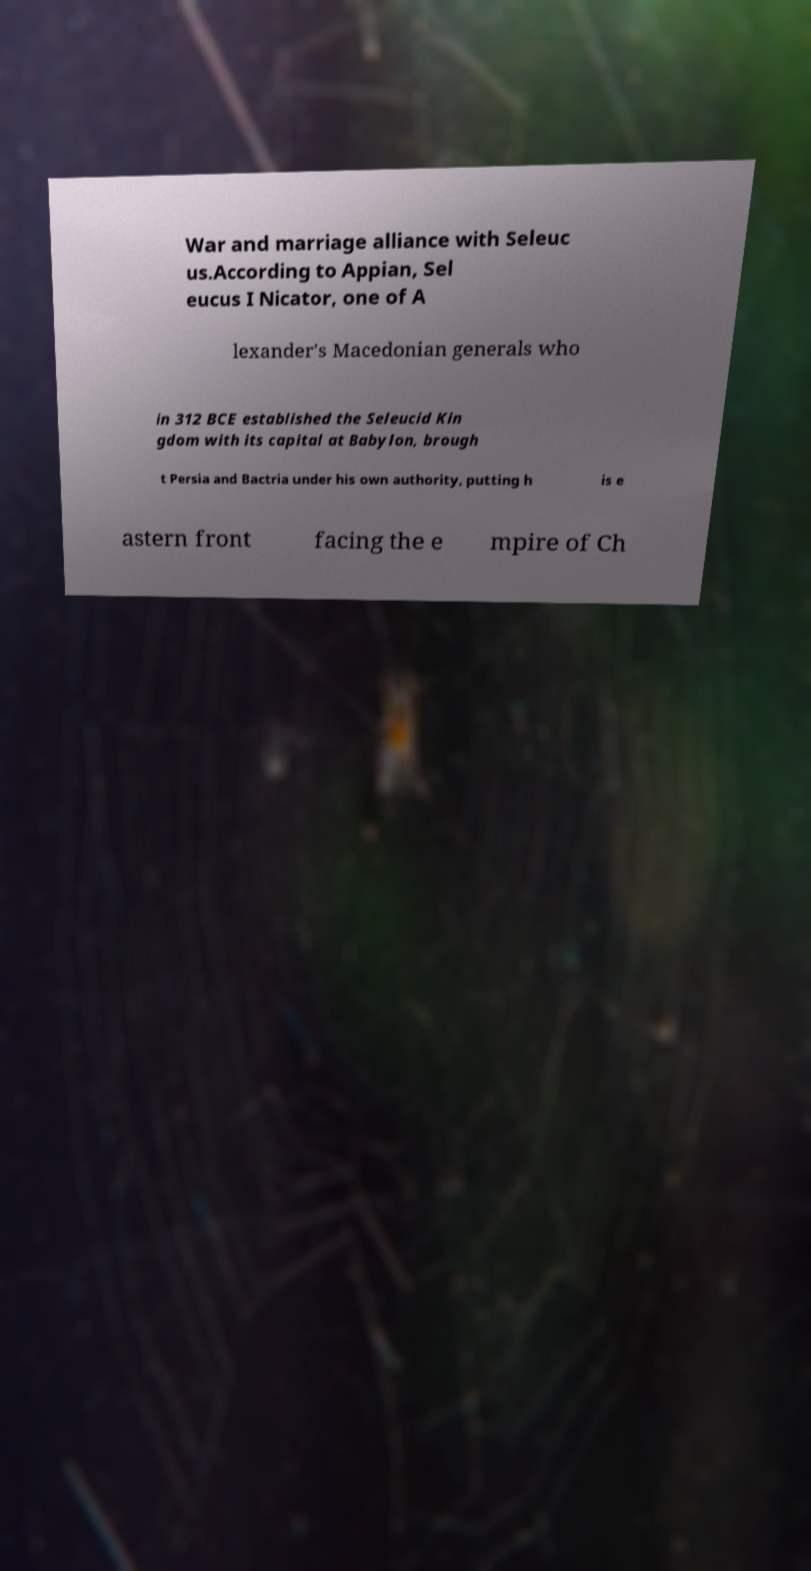Can you accurately transcribe the text from the provided image for me? War and marriage alliance with Seleuc us.According to Appian, Sel eucus I Nicator, one of A lexander's Macedonian generals who in 312 BCE established the Seleucid Kin gdom with its capital at Babylon, brough t Persia and Bactria under his own authority, putting h is e astern front facing the e mpire of Ch 